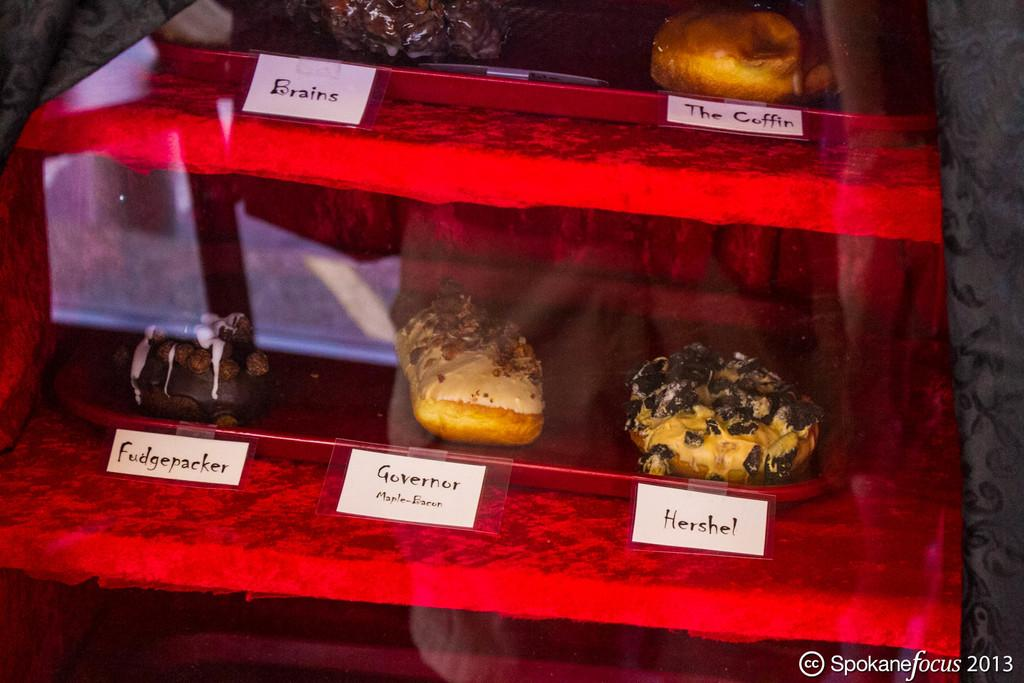<image>
Describe the image concisely. Several treats including one called The Coffin are behind a glass display. 